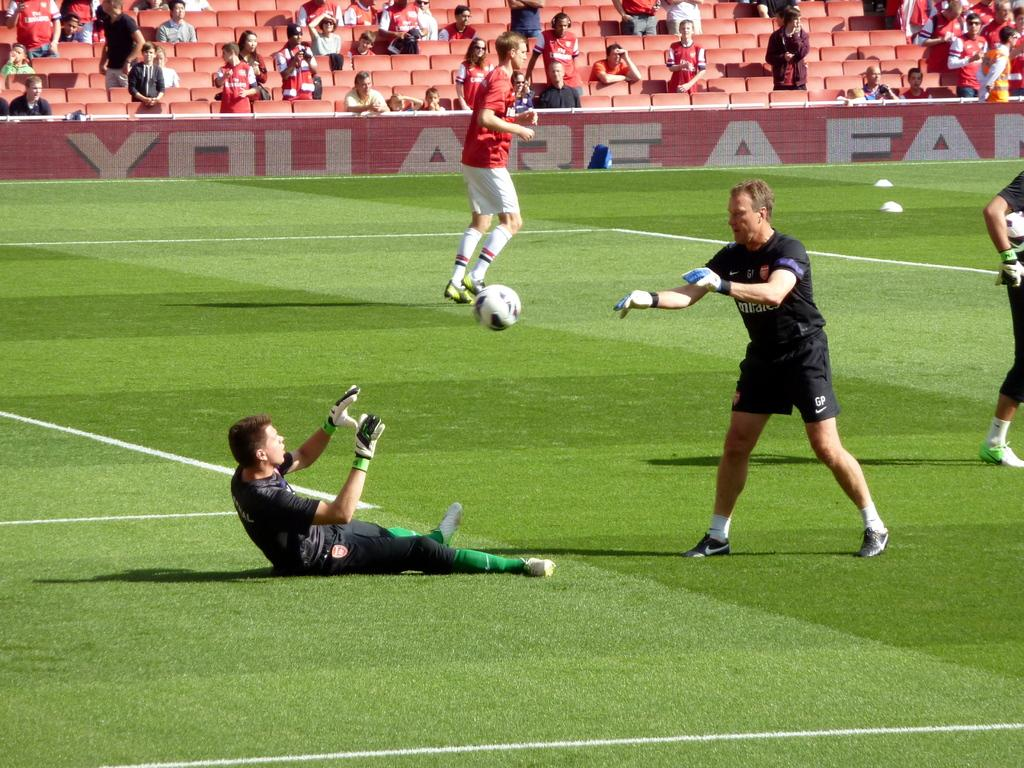Provide a one-sentence caption for the provided image. a football game with the words Your are a .. on the advertising hoard. 